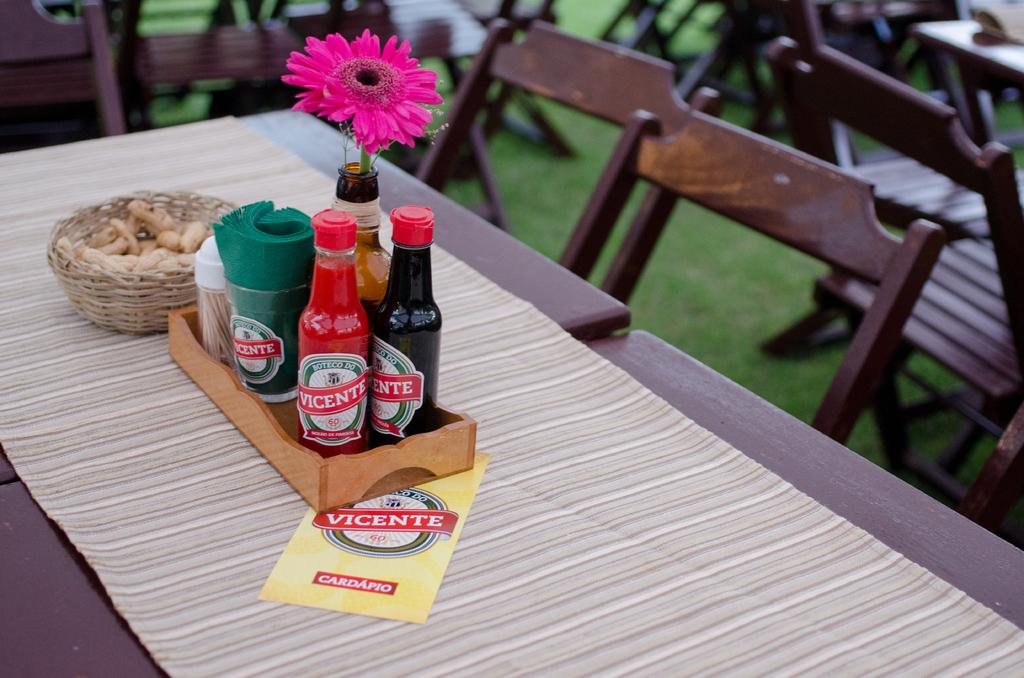<image>
Share a concise interpretation of the image provided. Several condiments from Vicente sit in a little wooden tray on the table. 